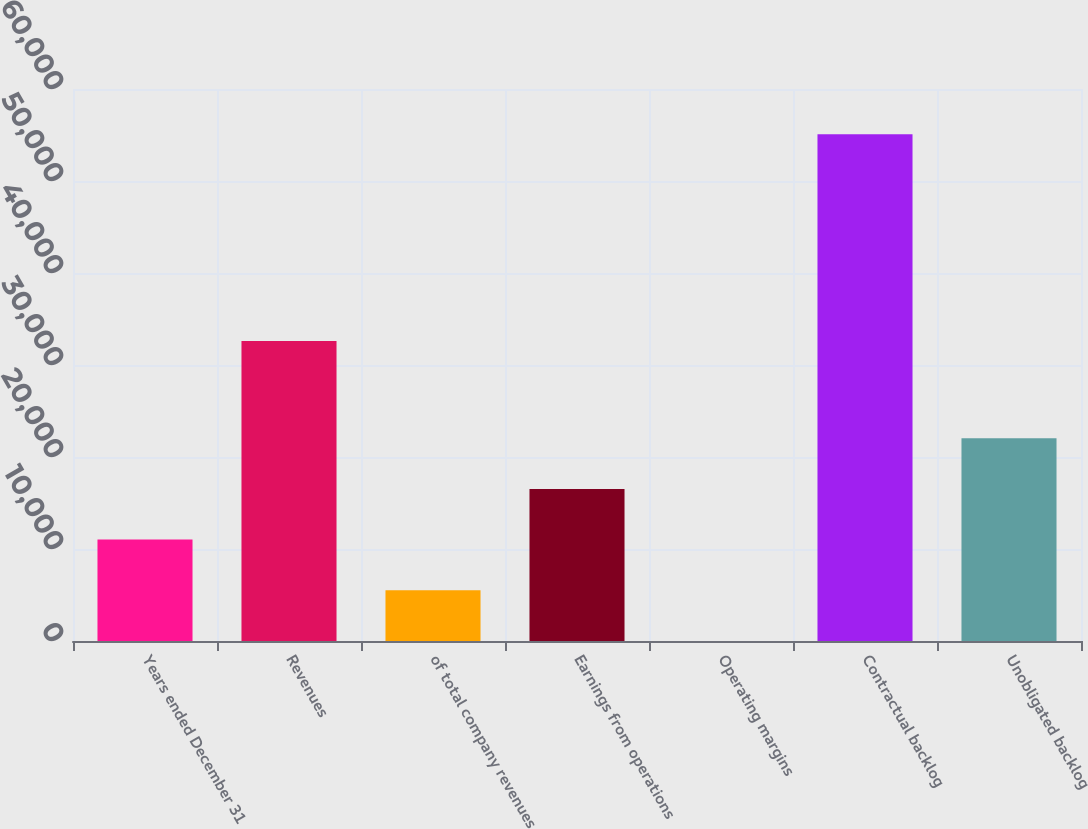<chart> <loc_0><loc_0><loc_500><loc_500><bar_chart><fcel>Years ended December 31<fcel>Revenues<fcel>of total company revenues<fcel>Earnings from operations<fcel>Operating margins<fcel>Contractual backlog<fcel>Unobligated backlog<nl><fcel>11021.1<fcel>32607<fcel>5515.26<fcel>16527<fcel>9.4<fcel>55068<fcel>22032.8<nl></chart> 